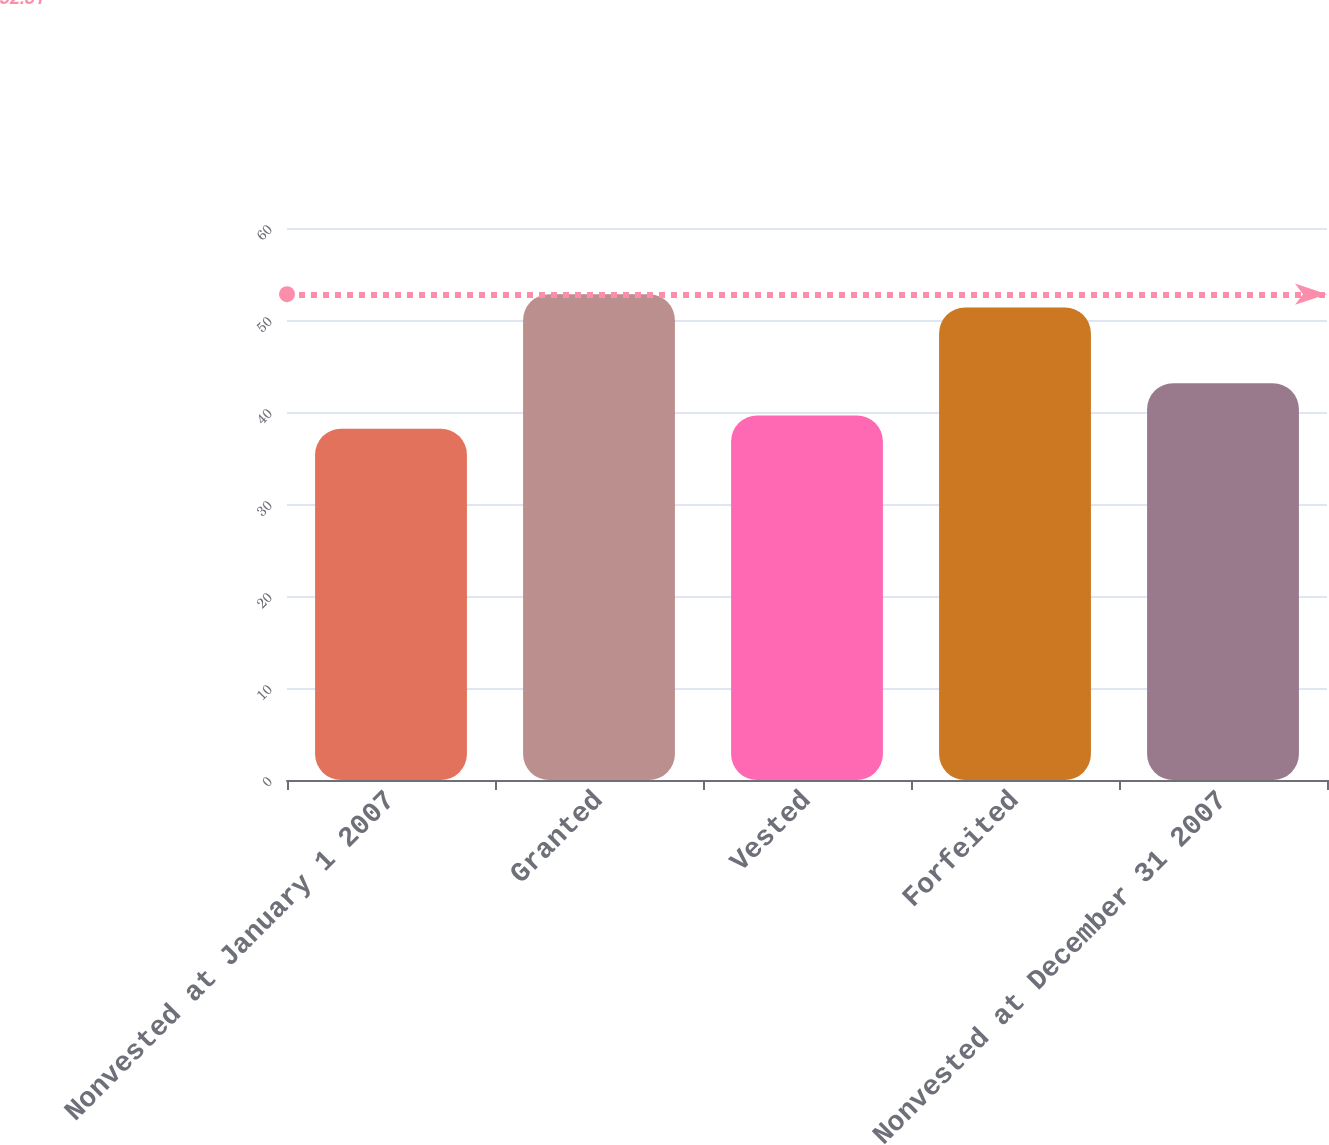<chart> <loc_0><loc_0><loc_500><loc_500><bar_chart><fcel>Nonvested at January 1 2007<fcel>Granted<fcel>Vested<fcel>Forfeited<fcel>Nonvested at December 31 2007<nl><fcel>38.18<fcel>52.81<fcel>39.62<fcel>51.37<fcel>43.13<nl></chart> 